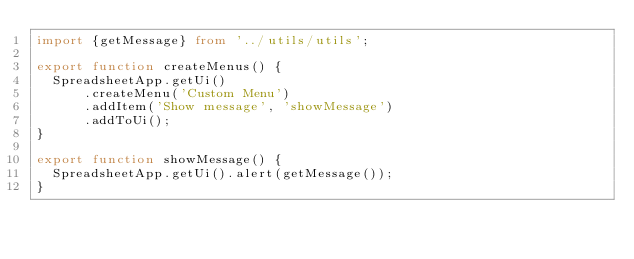<code> <loc_0><loc_0><loc_500><loc_500><_TypeScript_>import {getMessage} from '../utils/utils';

export function createMenus() {
  SpreadsheetApp.getUi()
      .createMenu('Custom Menu')
      .addItem('Show message', 'showMessage')
      .addToUi();
}

export function showMessage() {
  SpreadsheetApp.getUi().alert(getMessage());
}</code> 